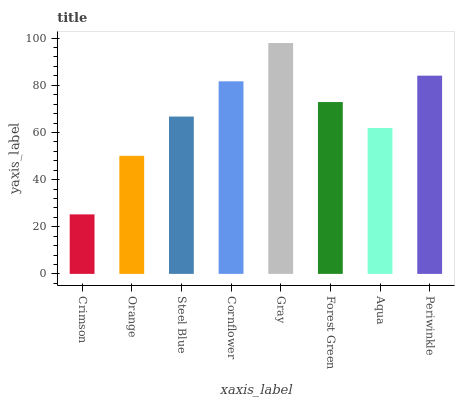Is Crimson the minimum?
Answer yes or no. Yes. Is Gray the maximum?
Answer yes or no. Yes. Is Orange the minimum?
Answer yes or no. No. Is Orange the maximum?
Answer yes or no. No. Is Orange greater than Crimson?
Answer yes or no. Yes. Is Crimson less than Orange?
Answer yes or no. Yes. Is Crimson greater than Orange?
Answer yes or no. No. Is Orange less than Crimson?
Answer yes or no. No. Is Forest Green the high median?
Answer yes or no. Yes. Is Steel Blue the low median?
Answer yes or no. Yes. Is Gray the high median?
Answer yes or no. No. Is Aqua the low median?
Answer yes or no. No. 